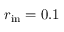Convert formula to latex. <formula><loc_0><loc_0><loc_500><loc_500>r _ { i n } = 0 . 1</formula> 